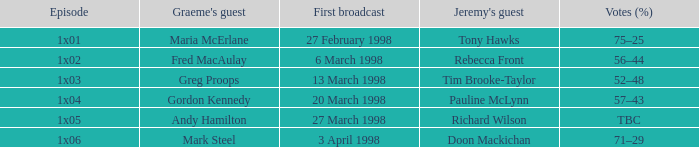What is Votes (%), when First Broadcast is "13 March 1998"? 52–48. 